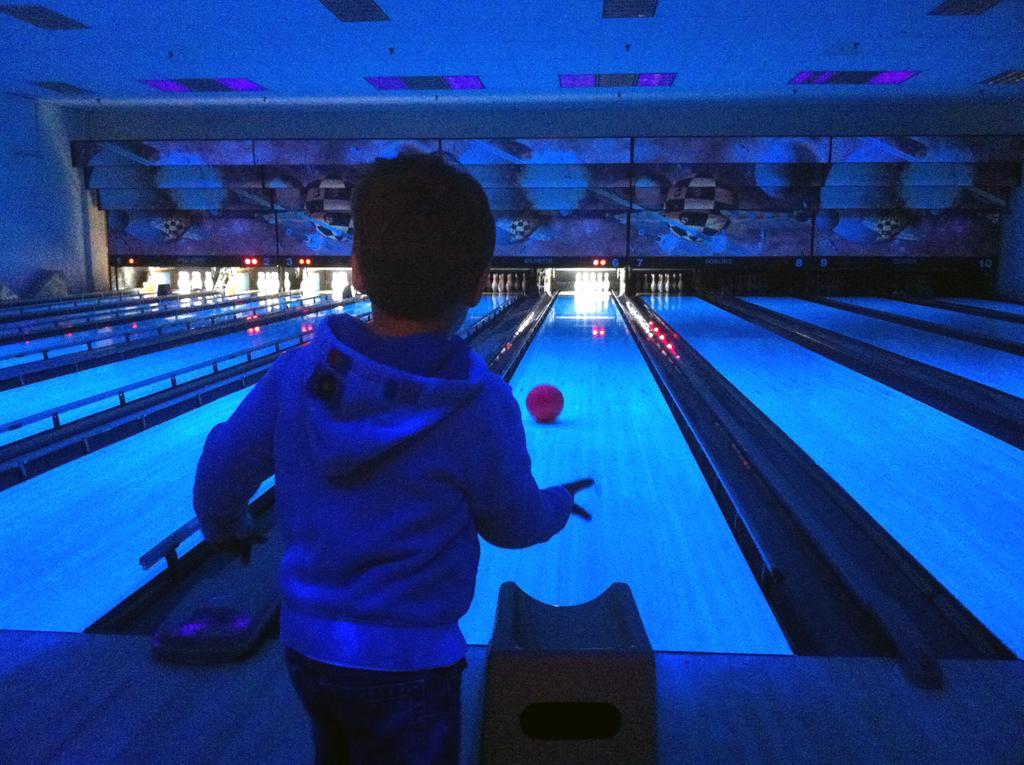Could you give a brief overview of what you see in this image? This is the picture of a room. In this image there is a boy standing in the foreground. At the back there is a ball on the floor and there are objects. At the top there are lights. 